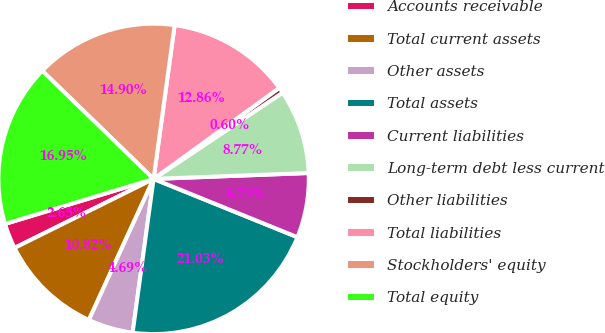Convert chart to OTSL. <chart><loc_0><loc_0><loc_500><loc_500><pie_chart><fcel>Accounts receivable<fcel>Total current assets<fcel>Other assets<fcel>Total assets<fcel>Current liabilities<fcel>Long-term debt less current<fcel>Other liabilities<fcel>Total liabilities<fcel>Stockholders' equity<fcel>Total equity<nl><fcel>2.65%<fcel>10.82%<fcel>4.69%<fcel>21.03%<fcel>6.73%<fcel>8.77%<fcel>0.6%<fcel>12.86%<fcel>14.9%<fcel>16.95%<nl></chart> 